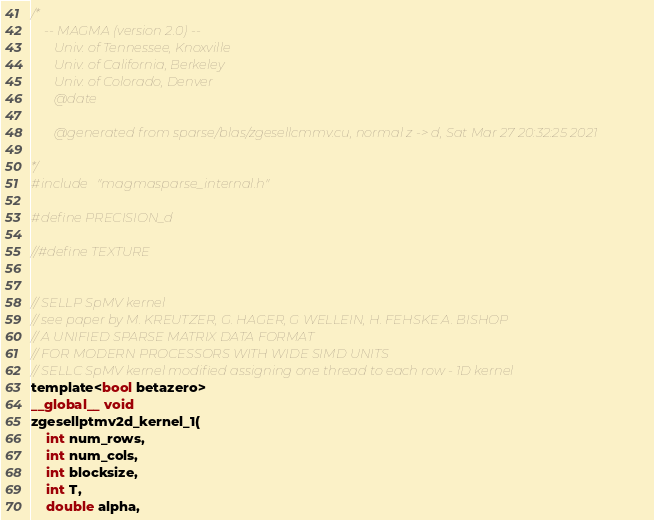Convert code to text. <code><loc_0><loc_0><loc_500><loc_500><_Cuda_>/*
    -- MAGMA (version 2.0) --
       Univ. of Tennessee, Knoxville
       Univ. of California, Berkeley
       Univ. of Colorado, Denver
       @date

       @generated from sparse/blas/zgesellcmmv.cu, normal z -> d, Sat Mar 27 20:32:25 2021

*/
#include "magmasparse_internal.h"

#define PRECISION_d

//#define TEXTURE


// SELLP SpMV kernel
// see paper by M. KREUTZER, G. HAGER, G WELLEIN, H. FEHSKE A. BISHOP
// A UNIFIED SPARSE MATRIX DATA FORMAT 
// FOR MODERN PROCESSORS WITH WIDE SIMD UNITS
// SELLC SpMV kernel modified assigning one thread to each row - 1D kernel
template<bool betazero>
__global__ void 
zgesellptmv2d_kernel_1( 
    int num_rows, 
    int num_cols,
    int blocksize,
    int T,
    double alpha, </code> 